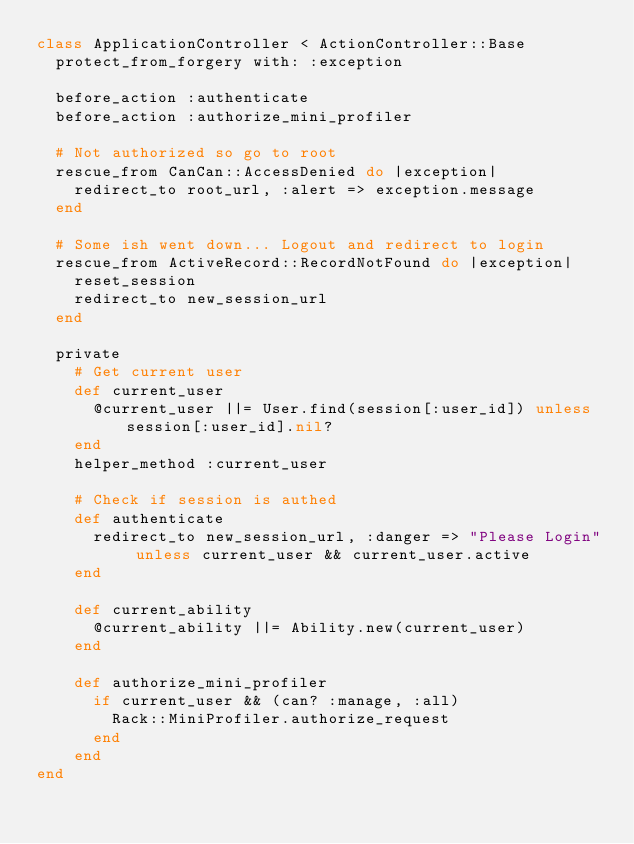Convert code to text. <code><loc_0><loc_0><loc_500><loc_500><_Ruby_>class ApplicationController < ActionController::Base
  protect_from_forgery with: :exception

  before_action :authenticate
  before_action :authorize_mini_profiler

  # Not authorized so go to root
  rescue_from CanCan::AccessDenied do |exception|
    redirect_to root_url, :alert => exception.message
  end

  # Some ish went down... Logout and redirect to login
  rescue_from ActiveRecord::RecordNotFound do |exception|
    reset_session
    redirect_to new_session_url
  end

  private
    # Get current user
    def current_user
      @current_user ||= User.find(session[:user_id]) unless session[:user_id].nil?
    end
    helper_method :current_user

    # Check if session is authed
    def authenticate
      redirect_to new_session_url, :danger => "Please Login" unless current_user && current_user.active
    end

    def current_ability
      @current_ability ||= Ability.new(current_user)
    end

    def authorize_mini_profiler
      if current_user && (can? :manage, :all)
        Rack::MiniProfiler.authorize_request
      end
    end
end
</code> 